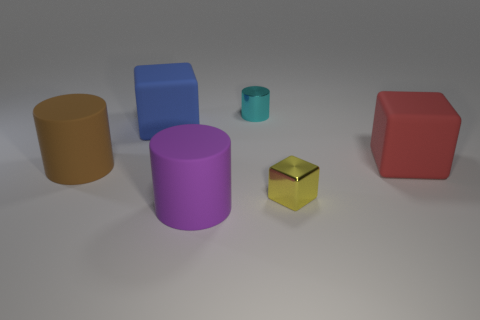The metal cylinder is what color?
Ensure brevity in your answer.  Cyan. Does the small metallic cylinder have the same color as the matte block that is behind the big red rubber cube?
Provide a succinct answer. No. What is the size of the blue cube that is made of the same material as the big purple thing?
Ensure brevity in your answer.  Large. Is there another small block of the same color as the shiny block?
Make the answer very short. No. What number of things are big objects that are in front of the large blue rubber thing or small cyan cylinders?
Ensure brevity in your answer.  4. Is the big blue object made of the same material as the cylinder that is in front of the tiny yellow cube?
Ensure brevity in your answer.  Yes. Is there a tiny cyan cylinder that has the same material as the blue object?
Offer a very short reply. No. What number of objects are matte cylinders that are right of the blue matte object or blocks left of the yellow thing?
Offer a terse response. 2. Is the shape of the small cyan thing the same as the purple matte object in front of the tiny shiny cube?
Provide a succinct answer. Yes. What number of other objects are the same shape as the yellow metal object?
Provide a short and direct response. 2. 